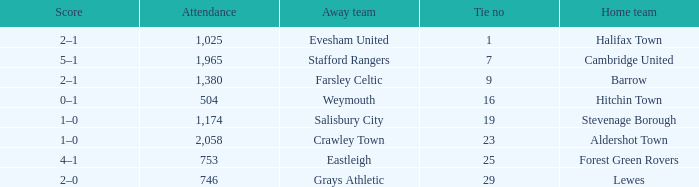Could you help me parse every detail presented in this table? {'header': ['Score', 'Attendance', 'Away team', 'Tie no', 'Home team'], 'rows': [['2–1', '1,025', 'Evesham United', '1', 'Halifax Town'], ['5–1', '1,965', 'Stafford Rangers', '7', 'Cambridge United'], ['2–1', '1,380', 'Farsley Celtic', '9', 'Barrow'], ['0–1', '504', 'Weymouth', '16', 'Hitchin Town'], ['1–0', '1,174', 'Salisbury City', '19', 'Stevenage Borough'], ['1–0', '2,058', 'Crawley Town', '23', 'Aldershot Town'], ['4–1', '753', 'Eastleigh', '25', 'Forest Green Rovers'], ['2–0', '746', 'Grays Athletic', '29', 'Lewes']]} Who was the away team in a tie no larger than 16 with forest green rovers at home? Eastleigh. 